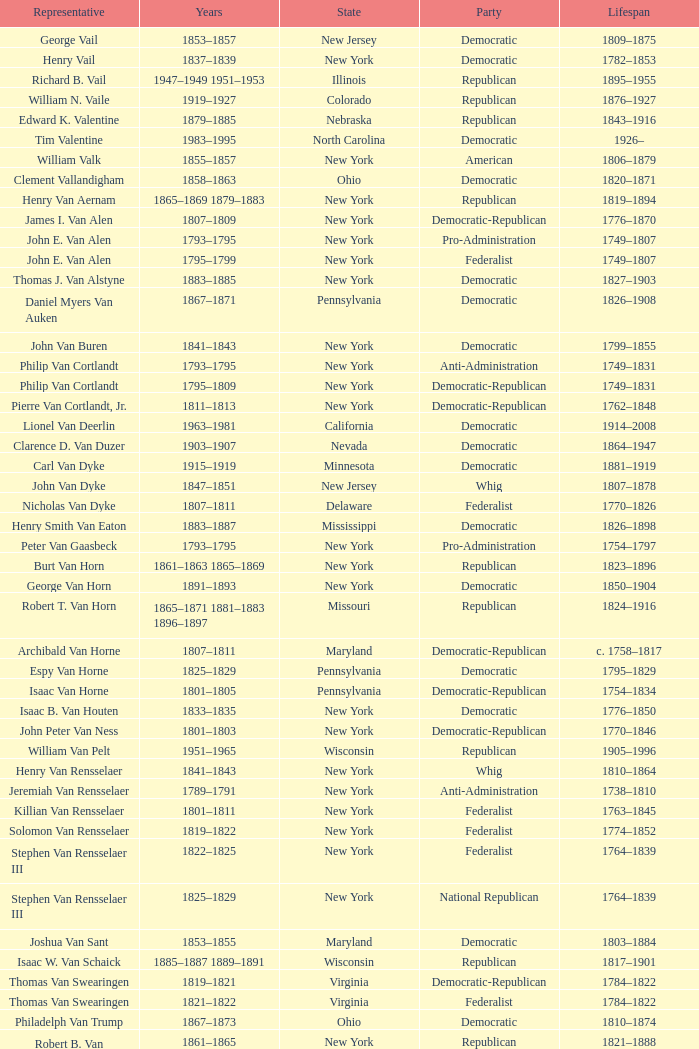What was the duration of joseph vance's life, an ohio-based democratic-republican? 1786–1852. 